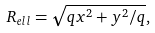<formula> <loc_0><loc_0><loc_500><loc_500>R _ { e l l } = \sqrt { q x ^ { 2 } + y ^ { 2 } / q } ,</formula> 